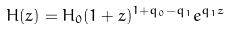Convert formula to latex. <formula><loc_0><loc_0><loc_500><loc_500>H ( z ) = H _ { 0 } ( 1 + z ) ^ { 1 + q _ { 0 } - q _ { 1 } } e ^ { q _ { 1 } z }</formula> 